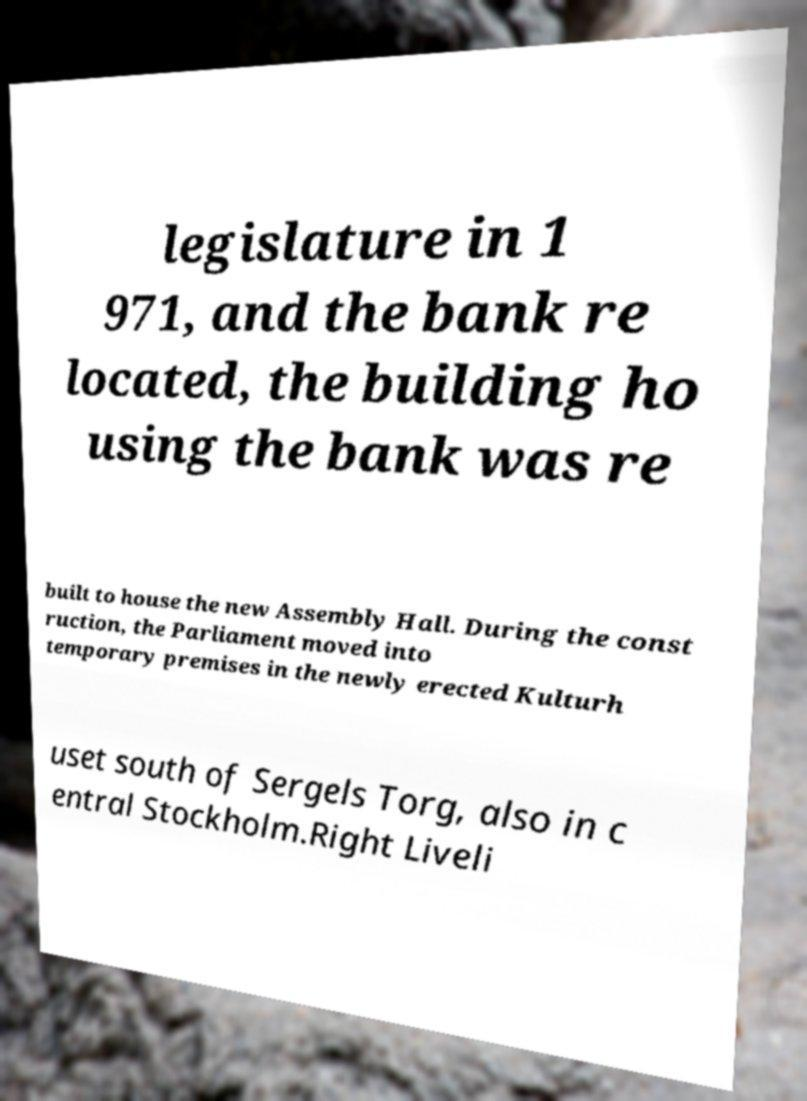Could you assist in decoding the text presented in this image and type it out clearly? legislature in 1 971, and the bank re located, the building ho using the bank was re built to house the new Assembly Hall. During the const ruction, the Parliament moved into temporary premises in the newly erected Kulturh uset south of Sergels Torg, also in c entral Stockholm.Right Liveli 